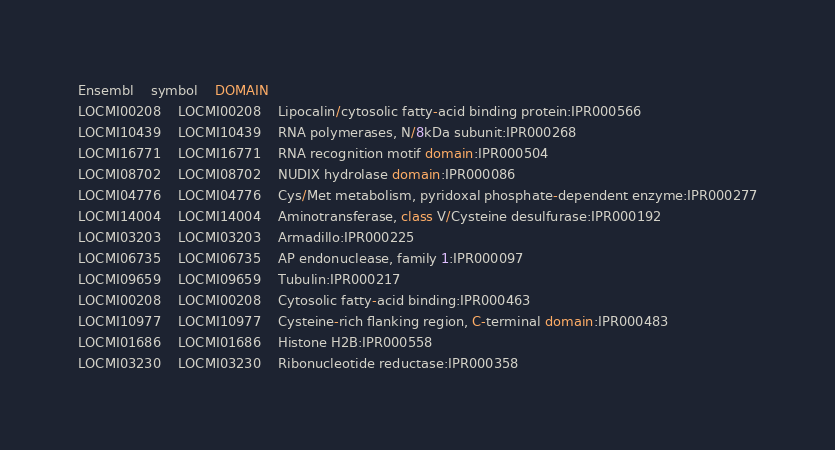Convert code to text. <code><loc_0><loc_0><loc_500><loc_500><_SQL_>Ensembl	symbol	DOMAIN
LOCMI00208	LOCMI00208	Lipocalin/cytosolic fatty-acid binding protein:IPR000566
LOCMI10439	LOCMI10439	RNA polymerases, N/8kDa subunit:IPR000268
LOCMI16771	LOCMI16771	RNA recognition motif domain:IPR000504
LOCMI08702	LOCMI08702	NUDIX hydrolase domain:IPR000086
LOCMI04776	LOCMI04776	Cys/Met metabolism, pyridoxal phosphate-dependent enzyme:IPR000277
LOCMI14004	LOCMI14004	Aminotransferase, class V/Cysteine desulfurase:IPR000192
LOCMI03203	LOCMI03203	Armadillo:IPR000225
LOCMI06735	LOCMI06735	AP endonuclease, family 1:IPR000097
LOCMI09659	LOCMI09659	Tubulin:IPR000217
LOCMI00208	LOCMI00208	Cytosolic fatty-acid binding:IPR000463
LOCMI10977	LOCMI10977	Cysteine-rich flanking region, C-terminal domain:IPR000483
LOCMI01686	LOCMI01686	Histone H2B:IPR000558
LOCMI03230	LOCMI03230	Ribonucleotide reductase:IPR000358
</code> 